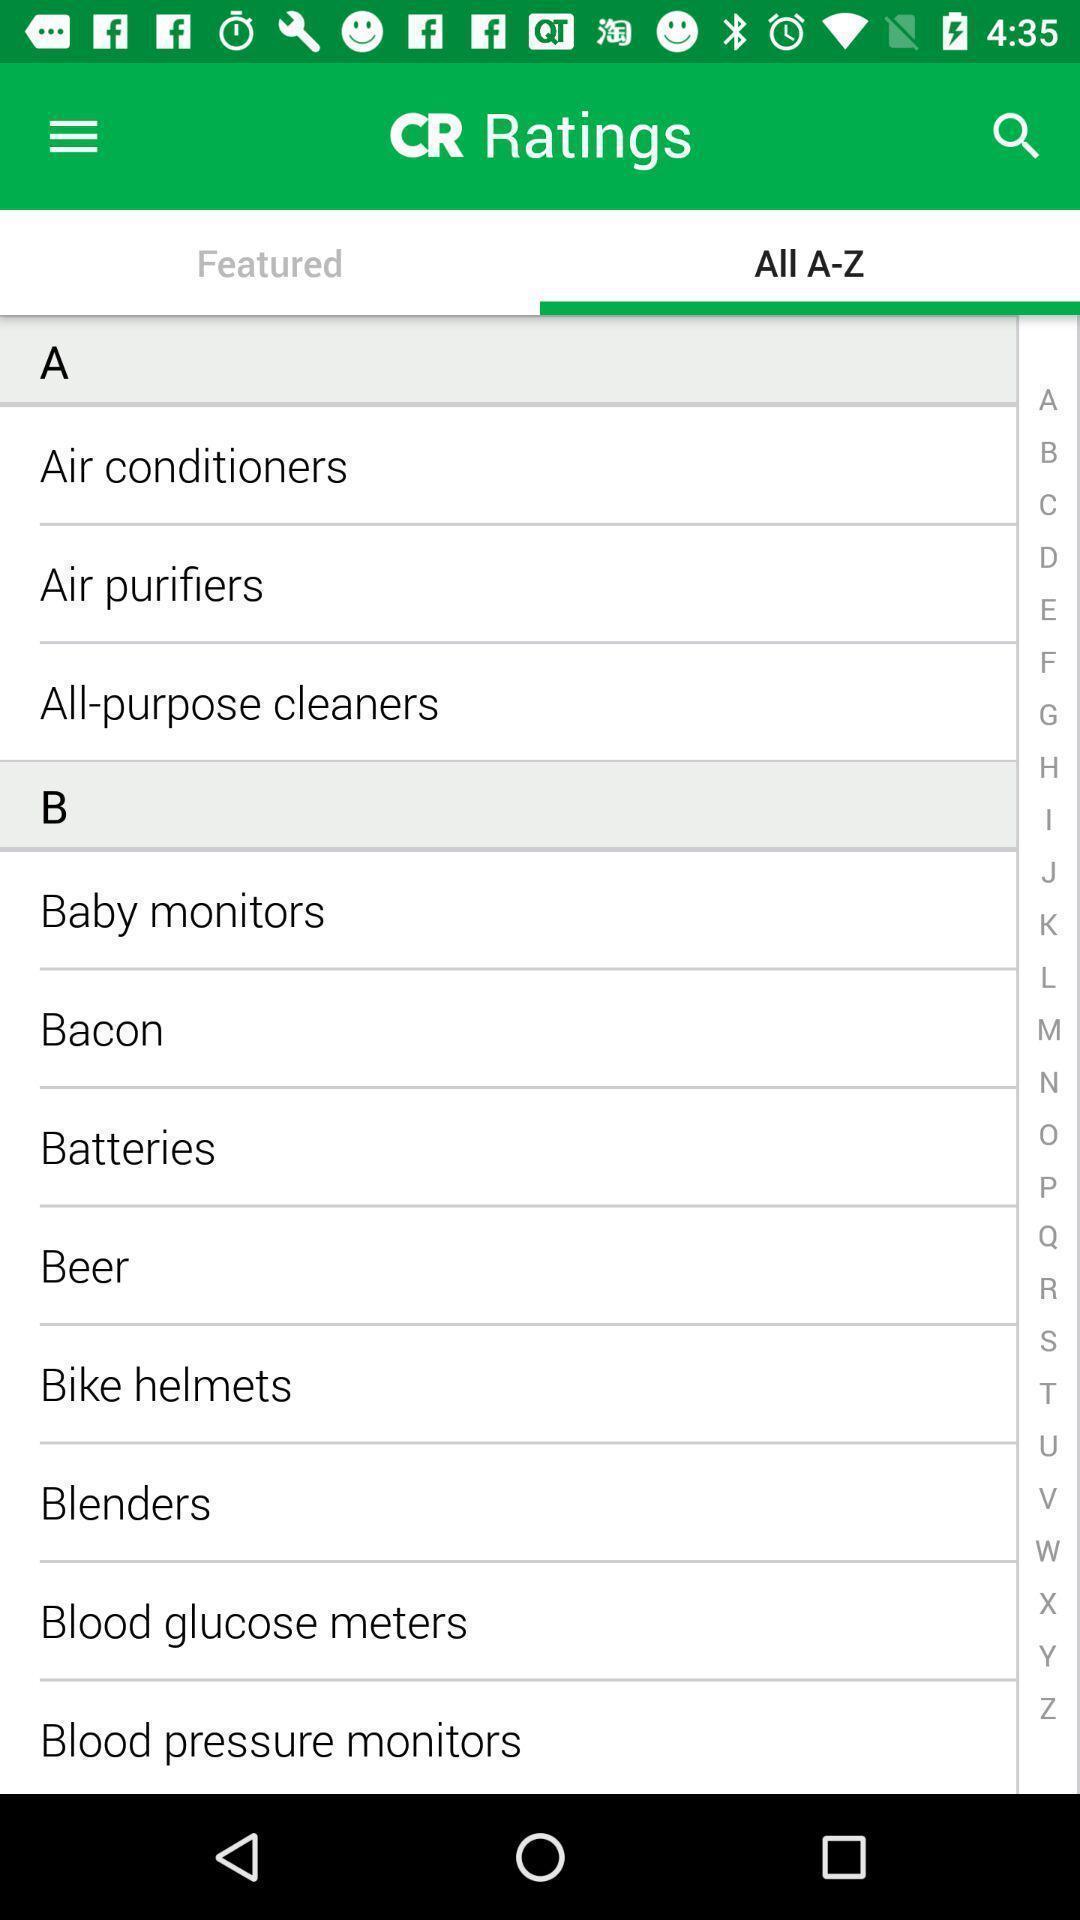Tell me what you see in this picture. Page displaying products list information about rating and review application. 